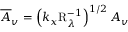Convert formula to latex. <formula><loc_0><loc_0><loc_500><loc_500>\overline { A } _ { v } = \left ( k _ { x } R _ { \lambda } ^ { - 1 } \right ) ^ { 1 / 2 } A _ { v }</formula> 